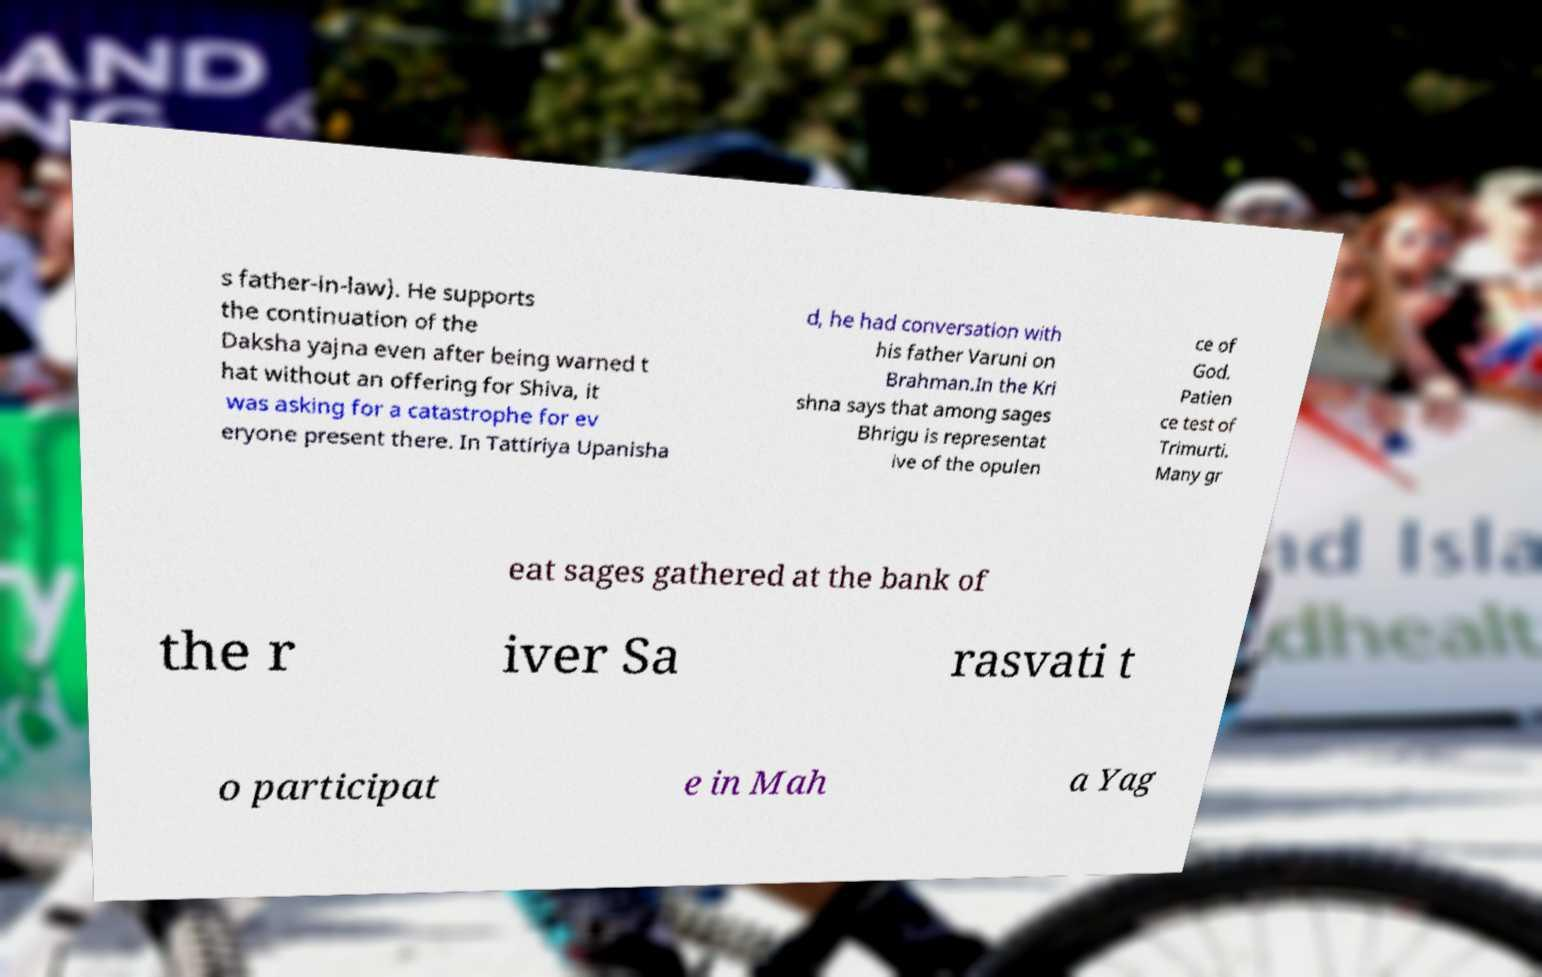Could you extract and type out the text from this image? s father-in-law). He supports the continuation of the Daksha yajna even after being warned t hat without an offering for Shiva, it was asking for a catastrophe for ev eryone present there. In Tattiriya Upanisha d, he had conversation with his father Varuni on Brahman.In the Kri shna says that among sages Bhrigu is representat ive of the opulen ce of God. Patien ce test of Trimurti. Many gr eat sages gathered at the bank of the r iver Sa rasvati t o participat e in Mah a Yag 